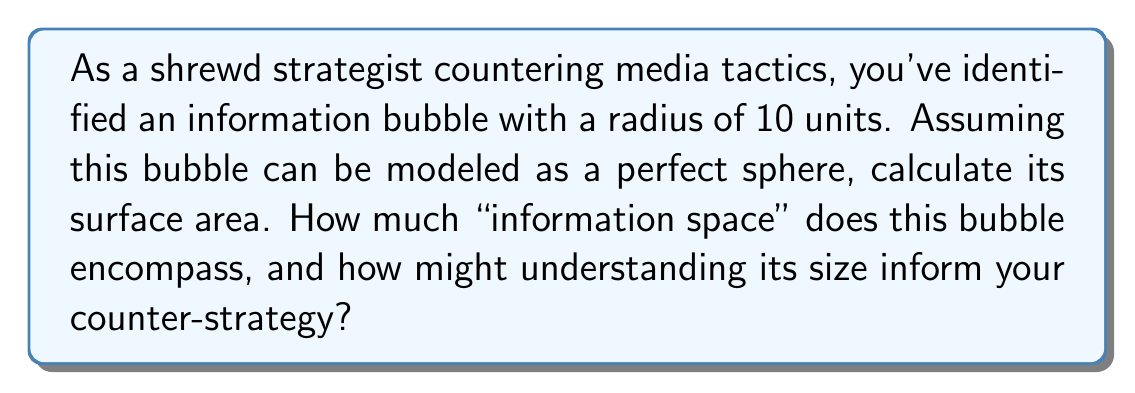Provide a solution to this math problem. To solve this problem, we need to use the formula for the surface area of a sphere:

$$A = 4\pi r^2$$

Where:
$A$ is the surface area
$\pi$ is pi (approximately 3.14159)
$r$ is the radius of the sphere

Given:
The radius of the information bubble is 10 units.

Step 1: Substitute the given radius into the formula.
$$A = 4\pi (10)^2$$

Step 2: Simplify the expression inside the parentheses.
$$A = 4\pi (100)$$

Step 3: Multiply.
$$A = 400\pi$$

Step 4: For a more precise numerical answer, we can use 3.14159 as an approximation for $\pi$.
$$A \approx 400 * 3.14159 = 1256.636 \text{ square units}$$

Understanding the size of this information bubble is crucial for developing a counter-strategy. A larger surface area implies a greater reach and influence of the information within the bubble. This knowledge can help in determining the scale of resources needed to effectively counter or penetrate the bubble's influence.
Answer: The surface area of the spherical information bubble is $400\pi$ square units, or approximately 1256.636 square units. 